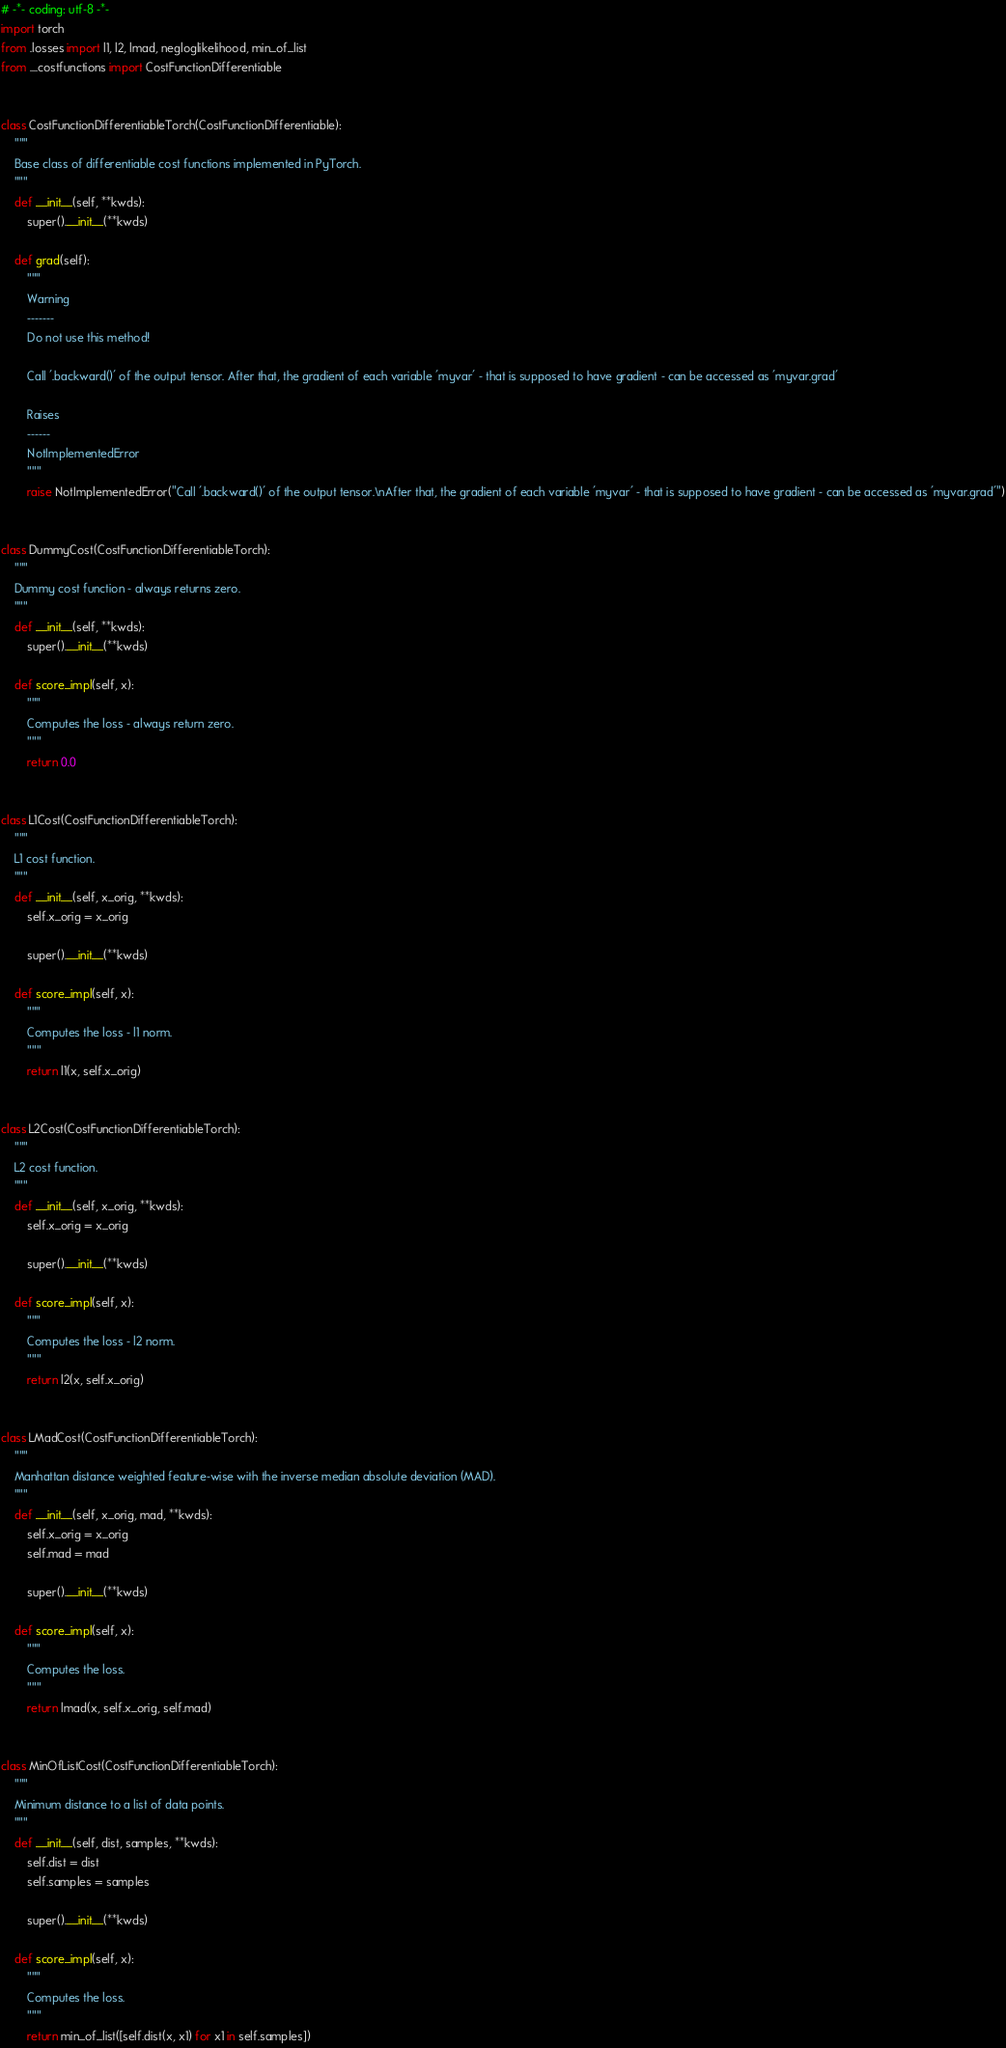Convert code to text. <code><loc_0><loc_0><loc_500><loc_500><_Python_># -*- coding: utf-8 -*-
import torch
from .losses import l1, l2, lmad, negloglikelihood, min_of_list
from ....costfunctions import CostFunctionDifferentiable


class CostFunctionDifferentiableTorch(CostFunctionDifferentiable):
    """
    Base class of differentiable cost functions implemented in PyTorch.
    """
    def __init__(self, **kwds):
        super().__init__(**kwds)
    
    def grad(self):
        """
        Warning
        -------
        Do not use this method!

        Call '.backward()' of the output tensor. After that, the gradient of each variable 'myvar' - that is supposed to have gradient - can be accessed as 'myvar.grad'

        Raises
        ------
        NotImplementedError
        """
        raise NotImplementedError("Call '.backward()' of the output tensor.\nAfter that, the gradient of each variable 'myvar' - that is supposed to have gradient - can be accessed as 'myvar.grad'")


class DummyCost(CostFunctionDifferentiableTorch):
    """
    Dummy cost function - always returns zero.
    """
    def __init__(self, **kwds):
        super().__init__(**kwds)
    
    def score_impl(self, x):
        """
        Computes the loss - always return zero.
        """
        return 0.0


class L1Cost(CostFunctionDifferentiableTorch):
    """
    L1 cost function.
    """
    def __init__(self, x_orig, **kwds):
        self.x_orig = x_orig

        super().__init__(**kwds)
    
    def score_impl(self, x):
        """
        Computes the loss - l1 norm.
        """
        return l1(x, self.x_orig) 


class L2Cost(CostFunctionDifferentiableTorch):
    """
    L2 cost function.
    """
    def __init__(self, x_orig, **kwds):
        self.x_orig = x_orig

        super().__init__(**kwds)
    
    def score_impl(self, x):
        """
        Computes the loss - l2 norm.
        """
        return l2(x, self.x_orig) 


class LMadCost(CostFunctionDifferentiableTorch):
    """
    Manhattan distance weighted feature-wise with the inverse median absolute deviation (MAD).
    """
    def __init__(self, x_orig, mad, **kwds):
        self.x_orig = x_orig
        self.mad = mad

        super().__init__(**kwds)
    
    def score_impl(self, x):
        """
        Computes the loss.
        """
        return lmad(x, self.x_orig, self.mad) 


class MinOfListCost(CostFunctionDifferentiableTorch):
    """
    Minimum distance to a list of data points.
    """
    def __init__(self, dist, samples, **kwds):
        self.dist = dist
        self.samples = samples

        super().__init__(**kwds)
    
    def score_impl(self, x):
        """
        Computes the loss.
        """
        return min_of_list([self.dist(x, x1) for x1 in self.samples])

</code> 